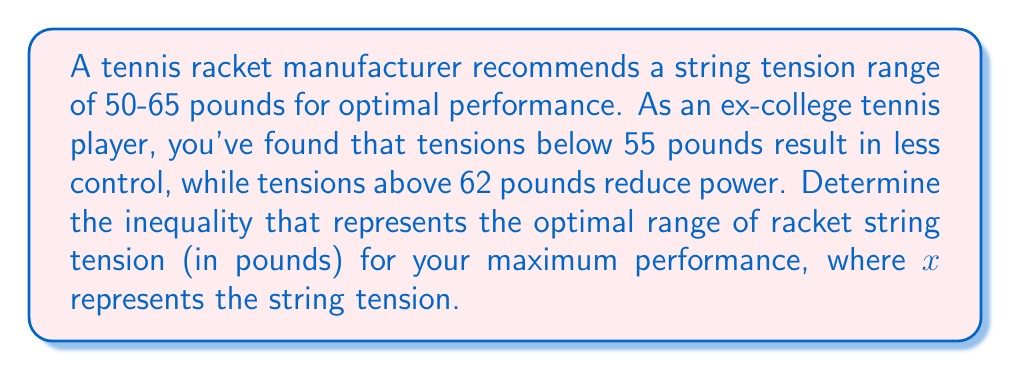What is the answer to this math problem? 1) First, let's identify the constraints:
   - The manufacturer's recommended range: $50 \leq x \leq 65$
   - Your lower limit for control: $x \geq 55$
   - Your upper limit for power: $x \leq 62$

2) To find the optimal range, we need to combine these constraints:
   - The lower bound will be the higher of the two lower limits: $\max(50, 55) = 55$
   - The upper bound will be the lower of the two upper limits: $\min(65, 62) = 62$

3) Therefore, the optimal range can be expressed as:
   $55 \leq x \leq 62$

4) This can be written as a compound inequality:
   $55 \leq x \text{ and } x \leq 62$

5) In interval notation, this would be written as $[55, 62]$.
Answer: $55 \leq x \leq 62$ 